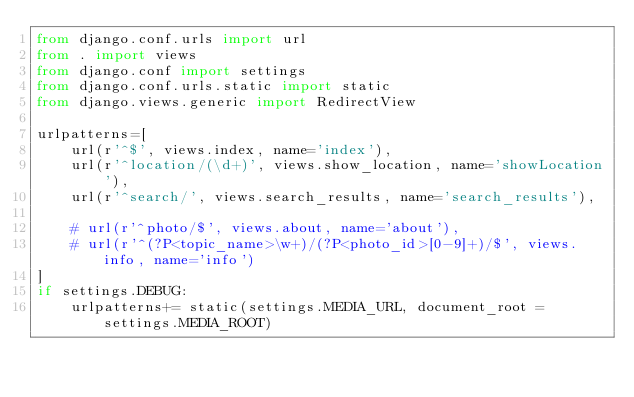<code> <loc_0><loc_0><loc_500><loc_500><_Python_>from django.conf.urls import url
from . import views
from django.conf import settings
from django.conf.urls.static import static
from django.views.generic import RedirectView

urlpatterns=[
    url(r'^$', views.index, name='index'),
    url(r'^location/(\d+)', views.show_location, name='showLocation'),
    url(r'^search/', views.search_results, name='search_results'),

    # url(r'^photo/$', views.about, name='about'),
    # url(r'^(?P<topic_name>\w+)/(?P<photo_id>[0-9]+)/$', views.info, name='info')
]
if settings.DEBUG:
    urlpatterns+= static(settings.MEDIA_URL, document_root = settings.MEDIA_ROOT)
</code> 